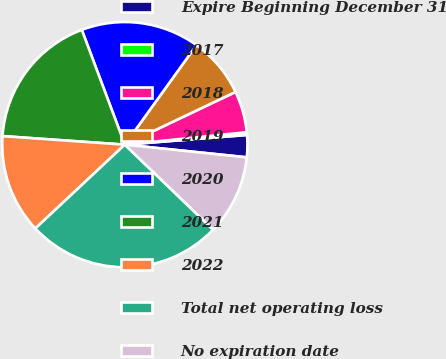<chart> <loc_0><loc_0><loc_500><loc_500><pie_chart><fcel>Expire Beginning December 31<fcel>2017<fcel>2018<fcel>2019<fcel>2020<fcel>2021<fcel>2022<fcel>Total net operating loss<fcel>No expiration date<nl><fcel>2.91%<fcel>0.36%<fcel>5.45%<fcel>8.0%<fcel>15.64%<fcel>18.18%<fcel>13.09%<fcel>25.82%<fcel>10.55%<nl></chart> 